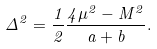Convert formula to latex. <formula><loc_0><loc_0><loc_500><loc_500>\Delta ^ { 2 } = \frac { 1 } { 2 } \frac { 4 \mu ^ { 2 } - M ^ { 2 } } { a + b } .</formula> 